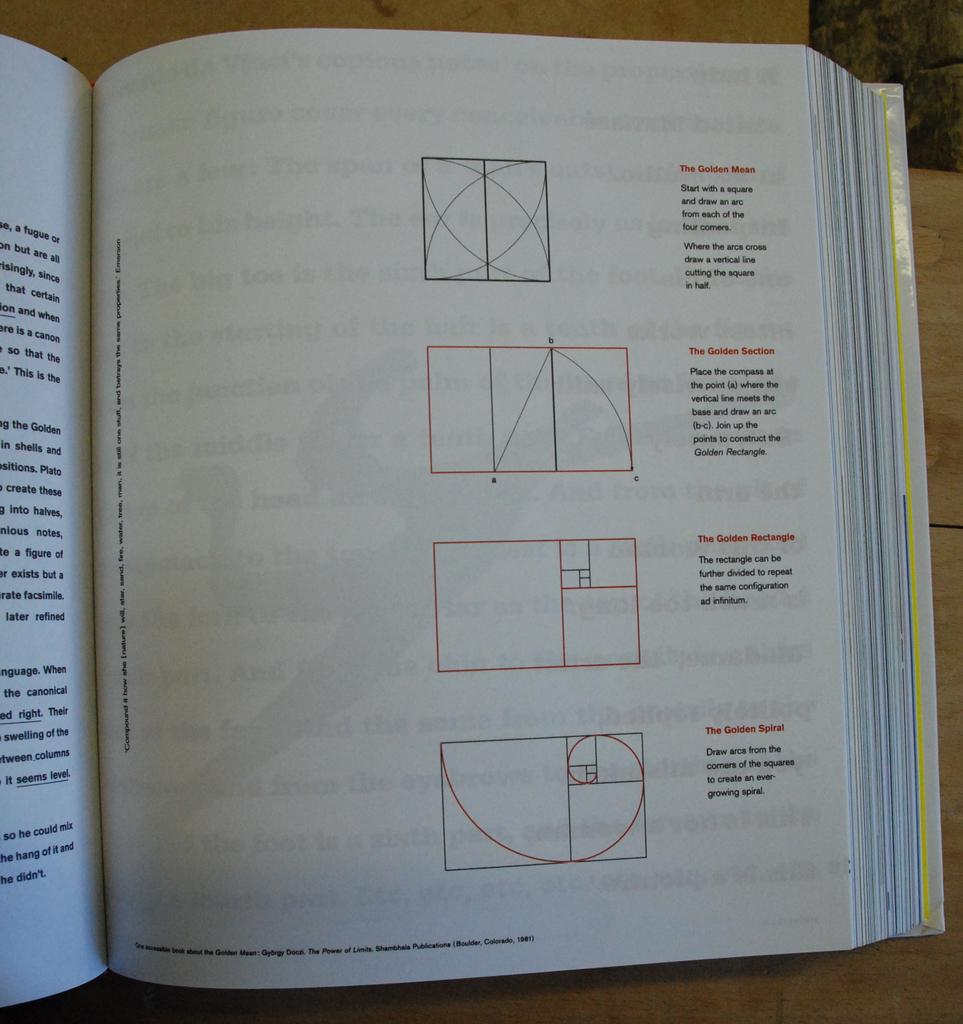<image>
Render a clear and concise summary of the photo. A book that discusses the golden mean, section, rectangle and spiral. 